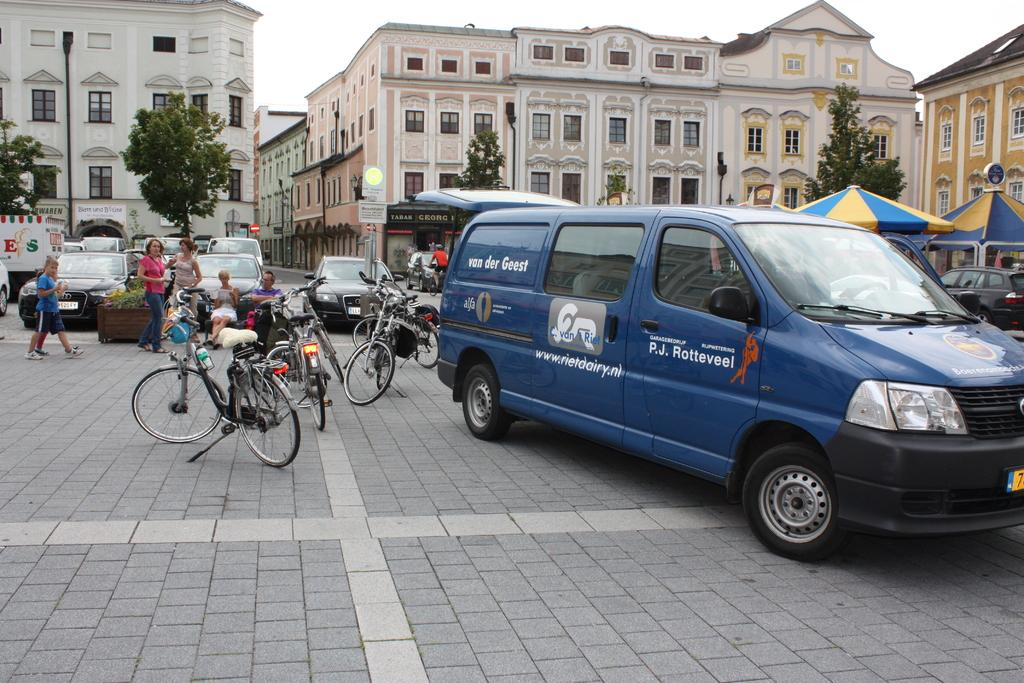<image>
Present a compact description of the photo's key features. A blue van next to some bicycles; the van has the words van der Geest on its side. 